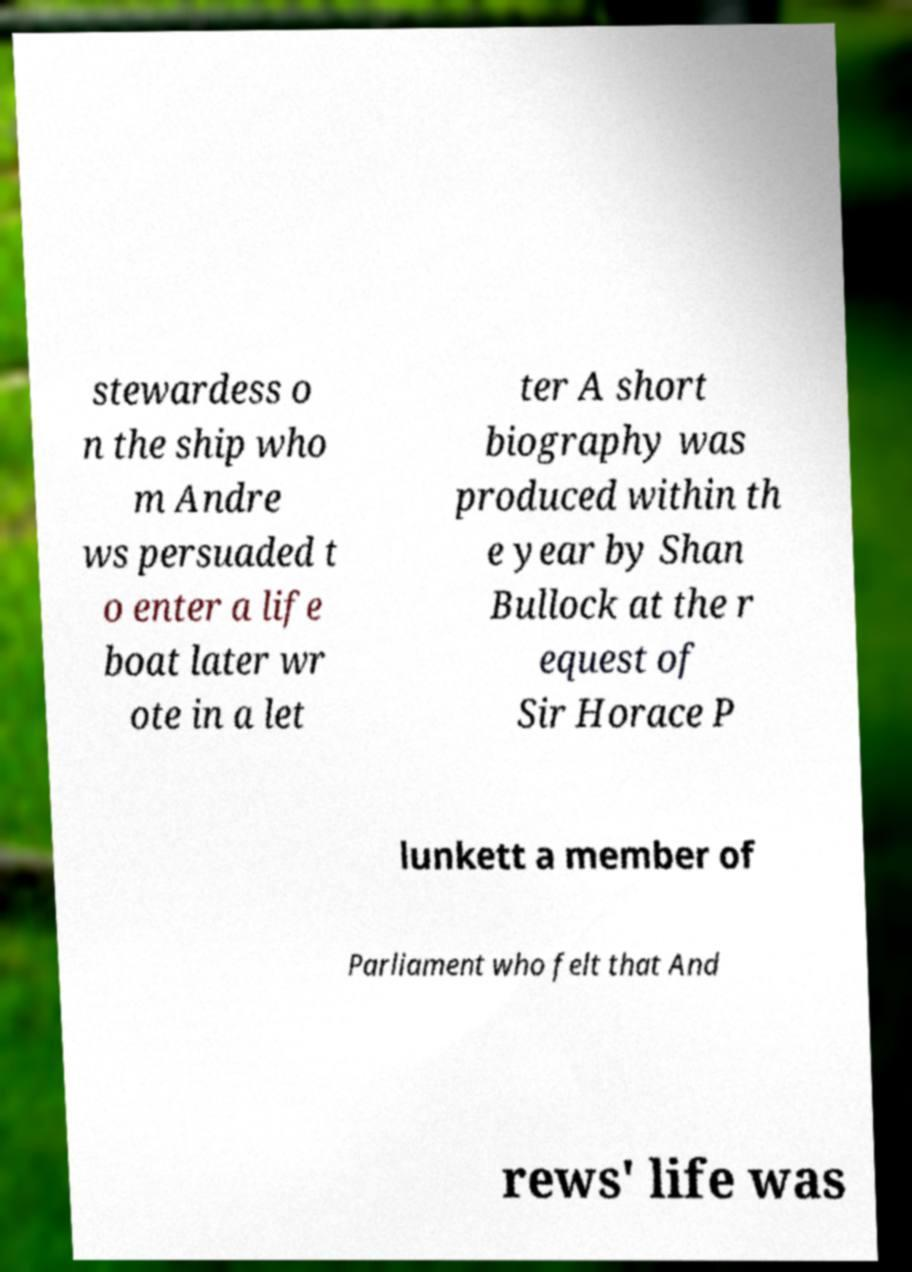Please read and relay the text visible in this image. What does it say? stewardess o n the ship who m Andre ws persuaded t o enter a life boat later wr ote in a let ter A short biography was produced within th e year by Shan Bullock at the r equest of Sir Horace P lunkett a member of Parliament who felt that And rews' life was 